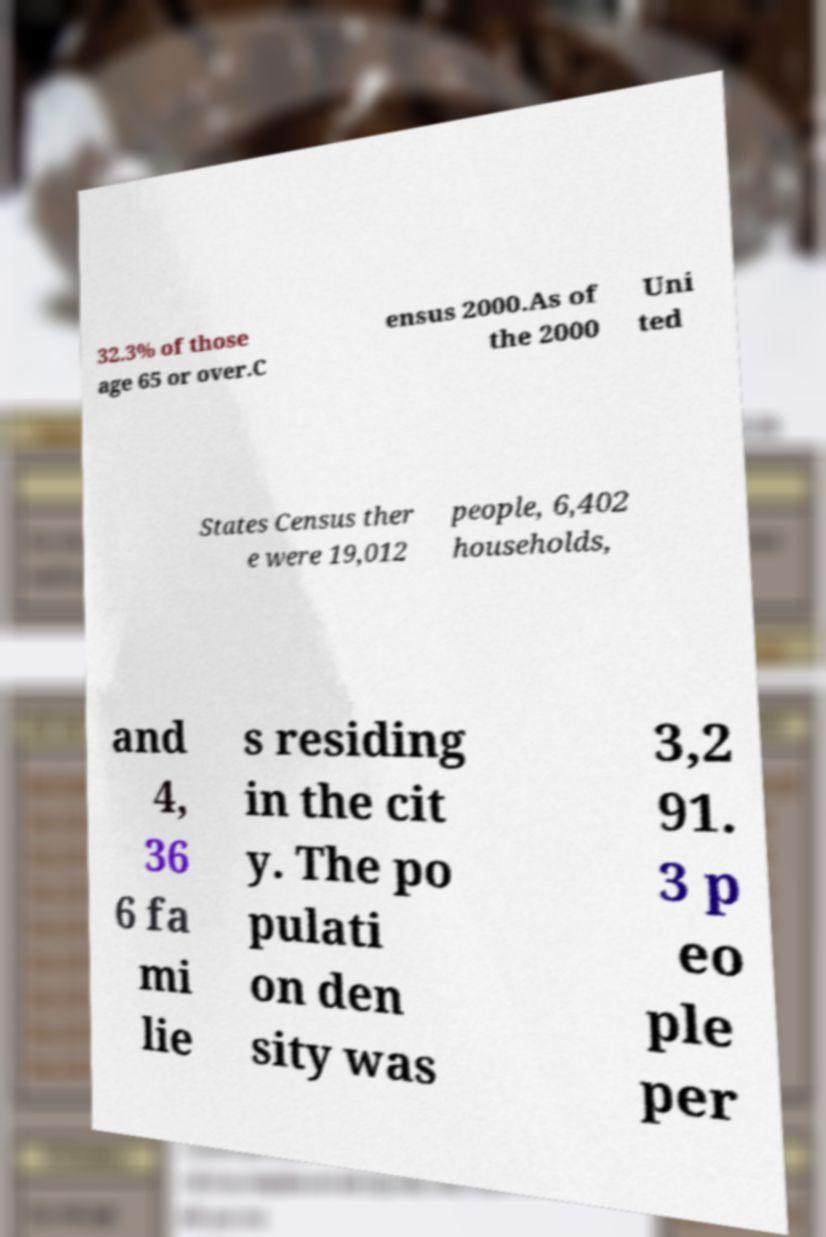Please read and relay the text visible in this image. What does it say? 32.3% of those age 65 or over.C ensus 2000.As of the 2000 Uni ted States Census ther e were 19,012 people, 6,402 households, and 4, 36 6 fa mi lie s residing in the cit y. The po pulati on den sity was 3,2 91. 3 p eo ple per 